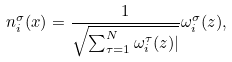Convert formula to latex. <formula><loc_0><loc_0><loc_500><loc_500>n _ { i } ^ { \sigma } ( x ) = \frac { 1 } { \sqrt { \sum _ { \tau = 1 } ^ { N } \omega _ { i } ^ { \tau } ( z ) | } } \omega _ { i } ^ { \sigma } ( z ) ,</formula> 